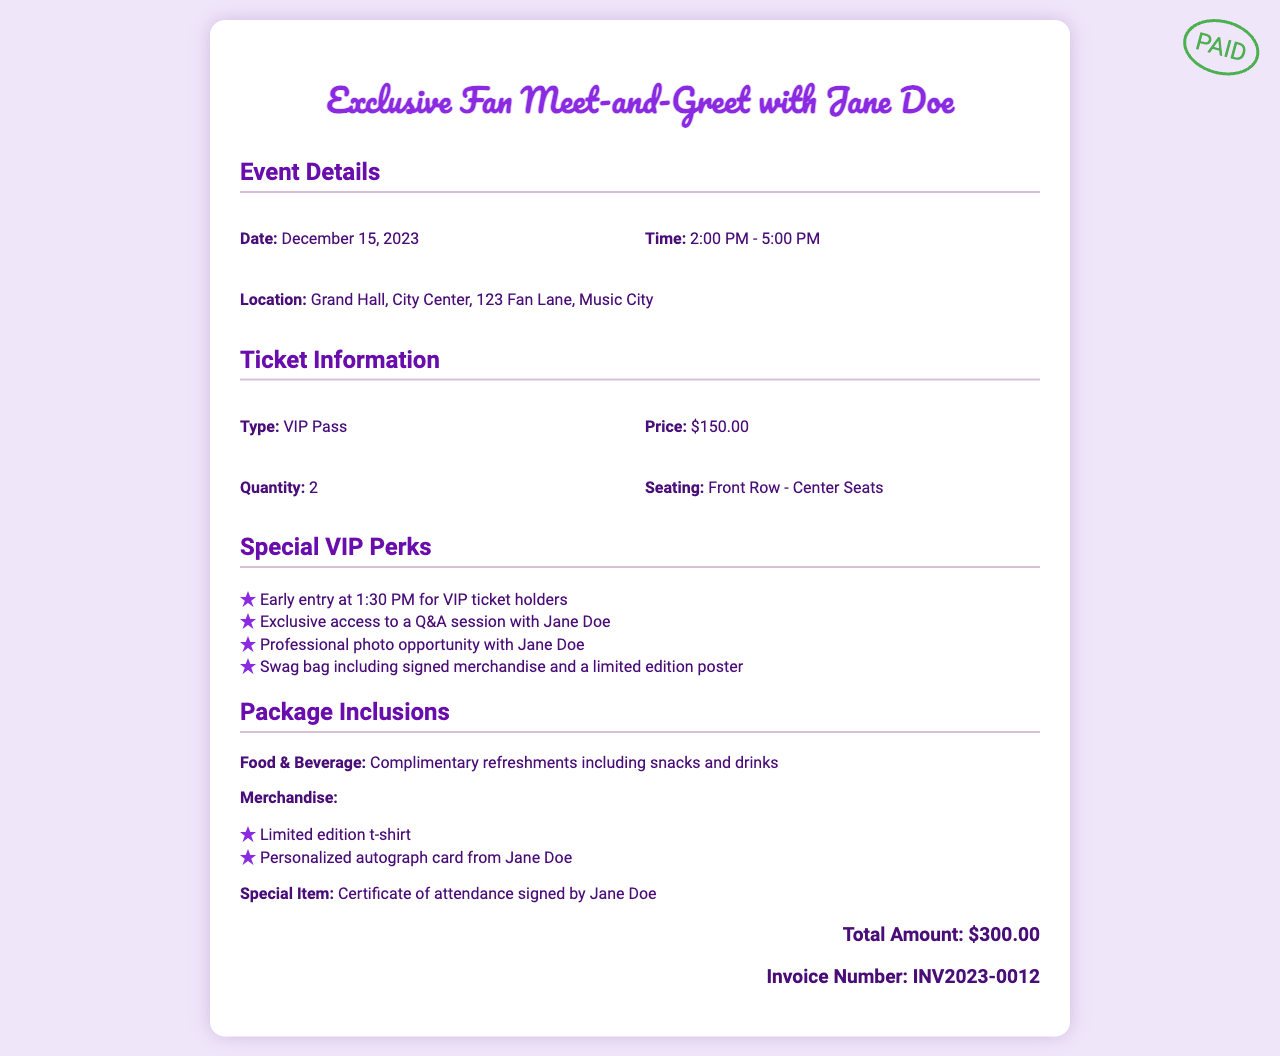what is the event date? The event date is located under event details in the document.
Answer: December 15, 2023 what is the price of a VIP pass? The price of the VIP pass is indicated in the ticket information section.
Answer: $150.00 how many tickets were purchased? The quantity of tickets purchased is mentioned in the ticket information.
Answer: 2 what are the special VIP perks? The list of special VIP perks is provided in the perks section of the document.
Answer: Early entry, Q&A session, photo opportunity, swag bag what is included in the merchandise? The inclusion of merchandise is detailed in the package inclusions section.
Answer: Limited edition t-shirt, personalized autograph card what is the time for the meet-and-greet? The time is specified under event details in the document.
Answer: 2:00 PM - 5:00 PM what is the total amount for the invoice? The total amount is displayed at the bottom of the invoice summary.
Answer: $300.00 what is the location of the event? The location can be found in the event details section of the invoice.
Answer: Grand Hall, City Center, 123 Fan Lane, Music City what items will attendees receive in the swag bag? The swag bag items are listed under special VIP perks in the document.
Answer: Signed merchandise, limited edition poster 